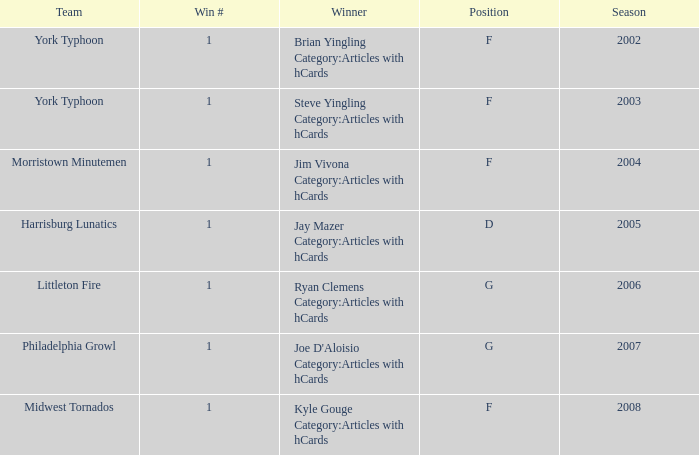Who was the winner in the 2008 season? Kyle Gouge Category:Articles with hCards. 